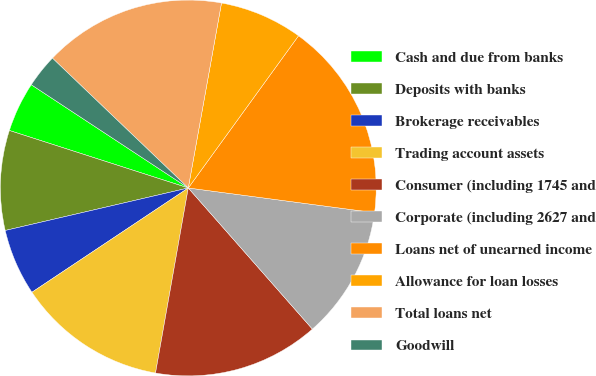Convert chart. <chart><loc_0><loc_0><loc_500><loc_500><pie_chart><fcel>Cash and due from banks<fcel>Deposits with banks<fcel>Brokerage receivables<fcel>Trading account assets<fcel>Consumer (including 1745 and<fcel>Corporate (including 2627 and<fcel>Loans net of unearned income<fcel>Allowance for loan losses<fcel>Total loans net<fcel>Goodwill<nl><fcel>4.31%<fcel>8.58%<fcel>5.73%<fcel>12.85%<fcel>14.27%<fcel>11.42%<fcel>17.12%<fcel>7.15%<fcel>15.69%<fcel>2.88%<nl></chart> 